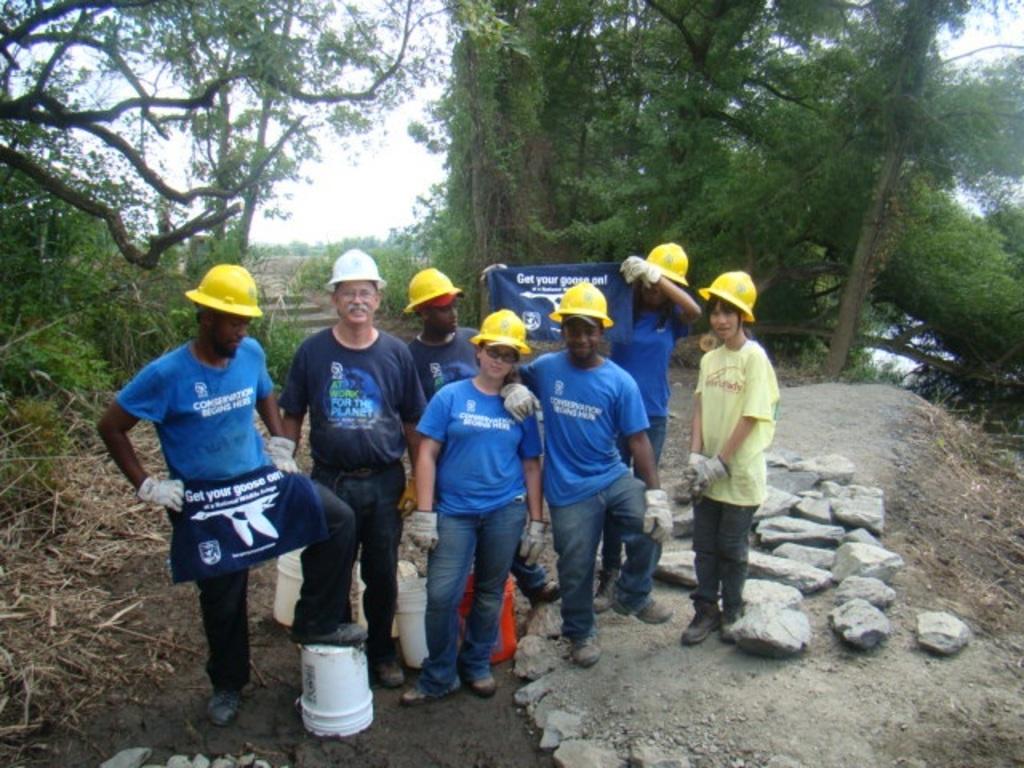What is the header on the sign?
Offer a very short reply. Get your goose on. 